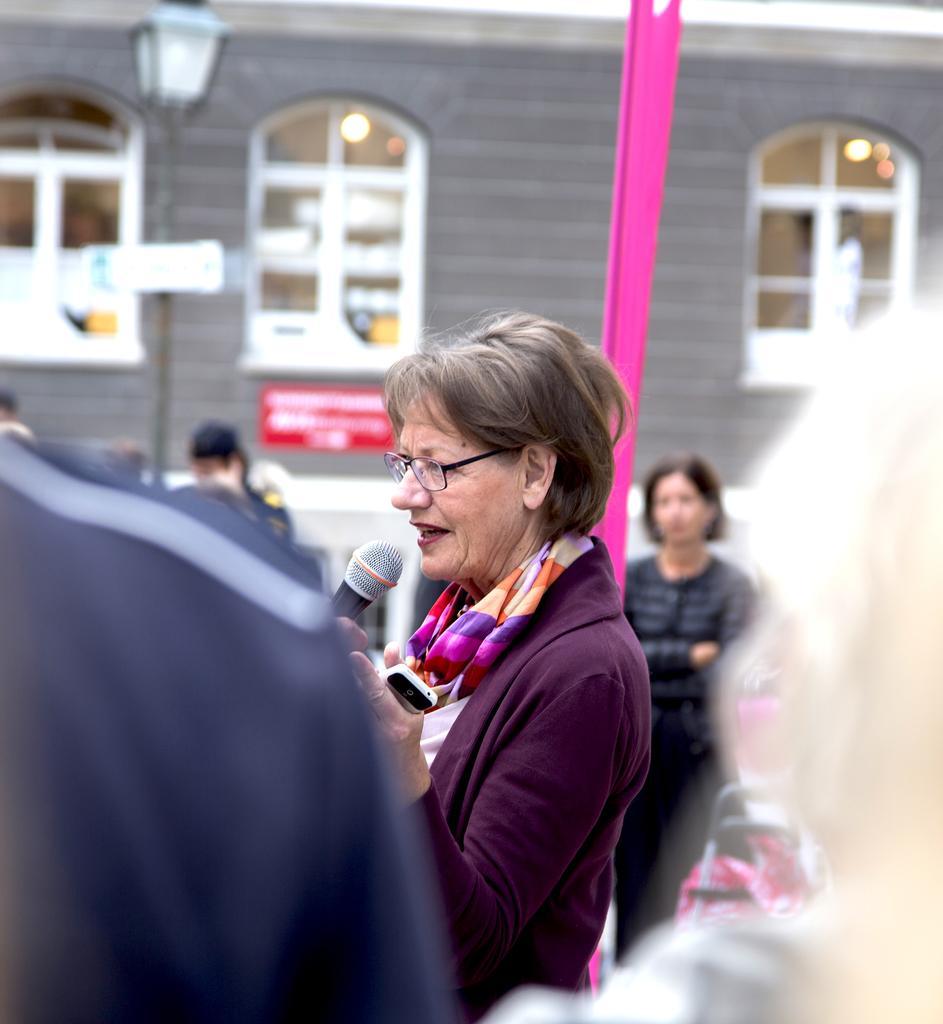Could you give a brief overview of what you see in this image? In the center of the image we can see a lady standing and holding a mobile and a mic. There are people. In the background we can see a building. On the left there is a pole and we can see windows. On the right there is a trolley. 